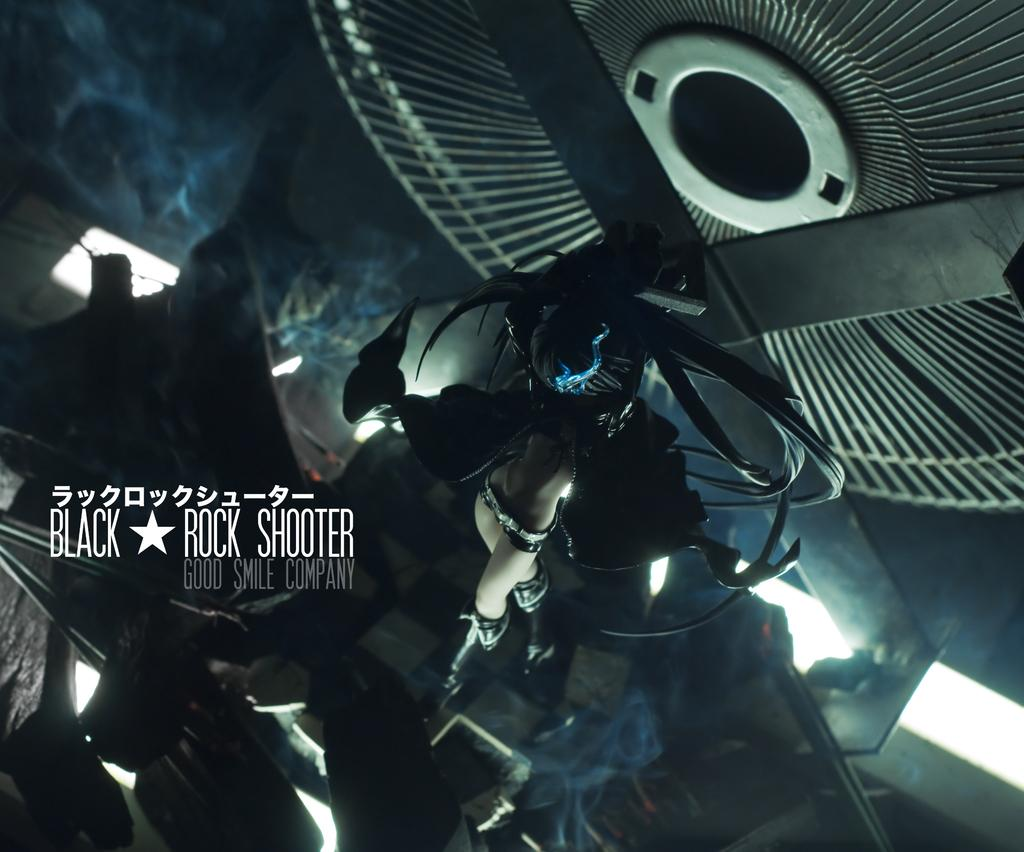<image>
Provide a brief description of the given image. a very dark image with a woman who appears to be flying labeled Black Rock Shooter 